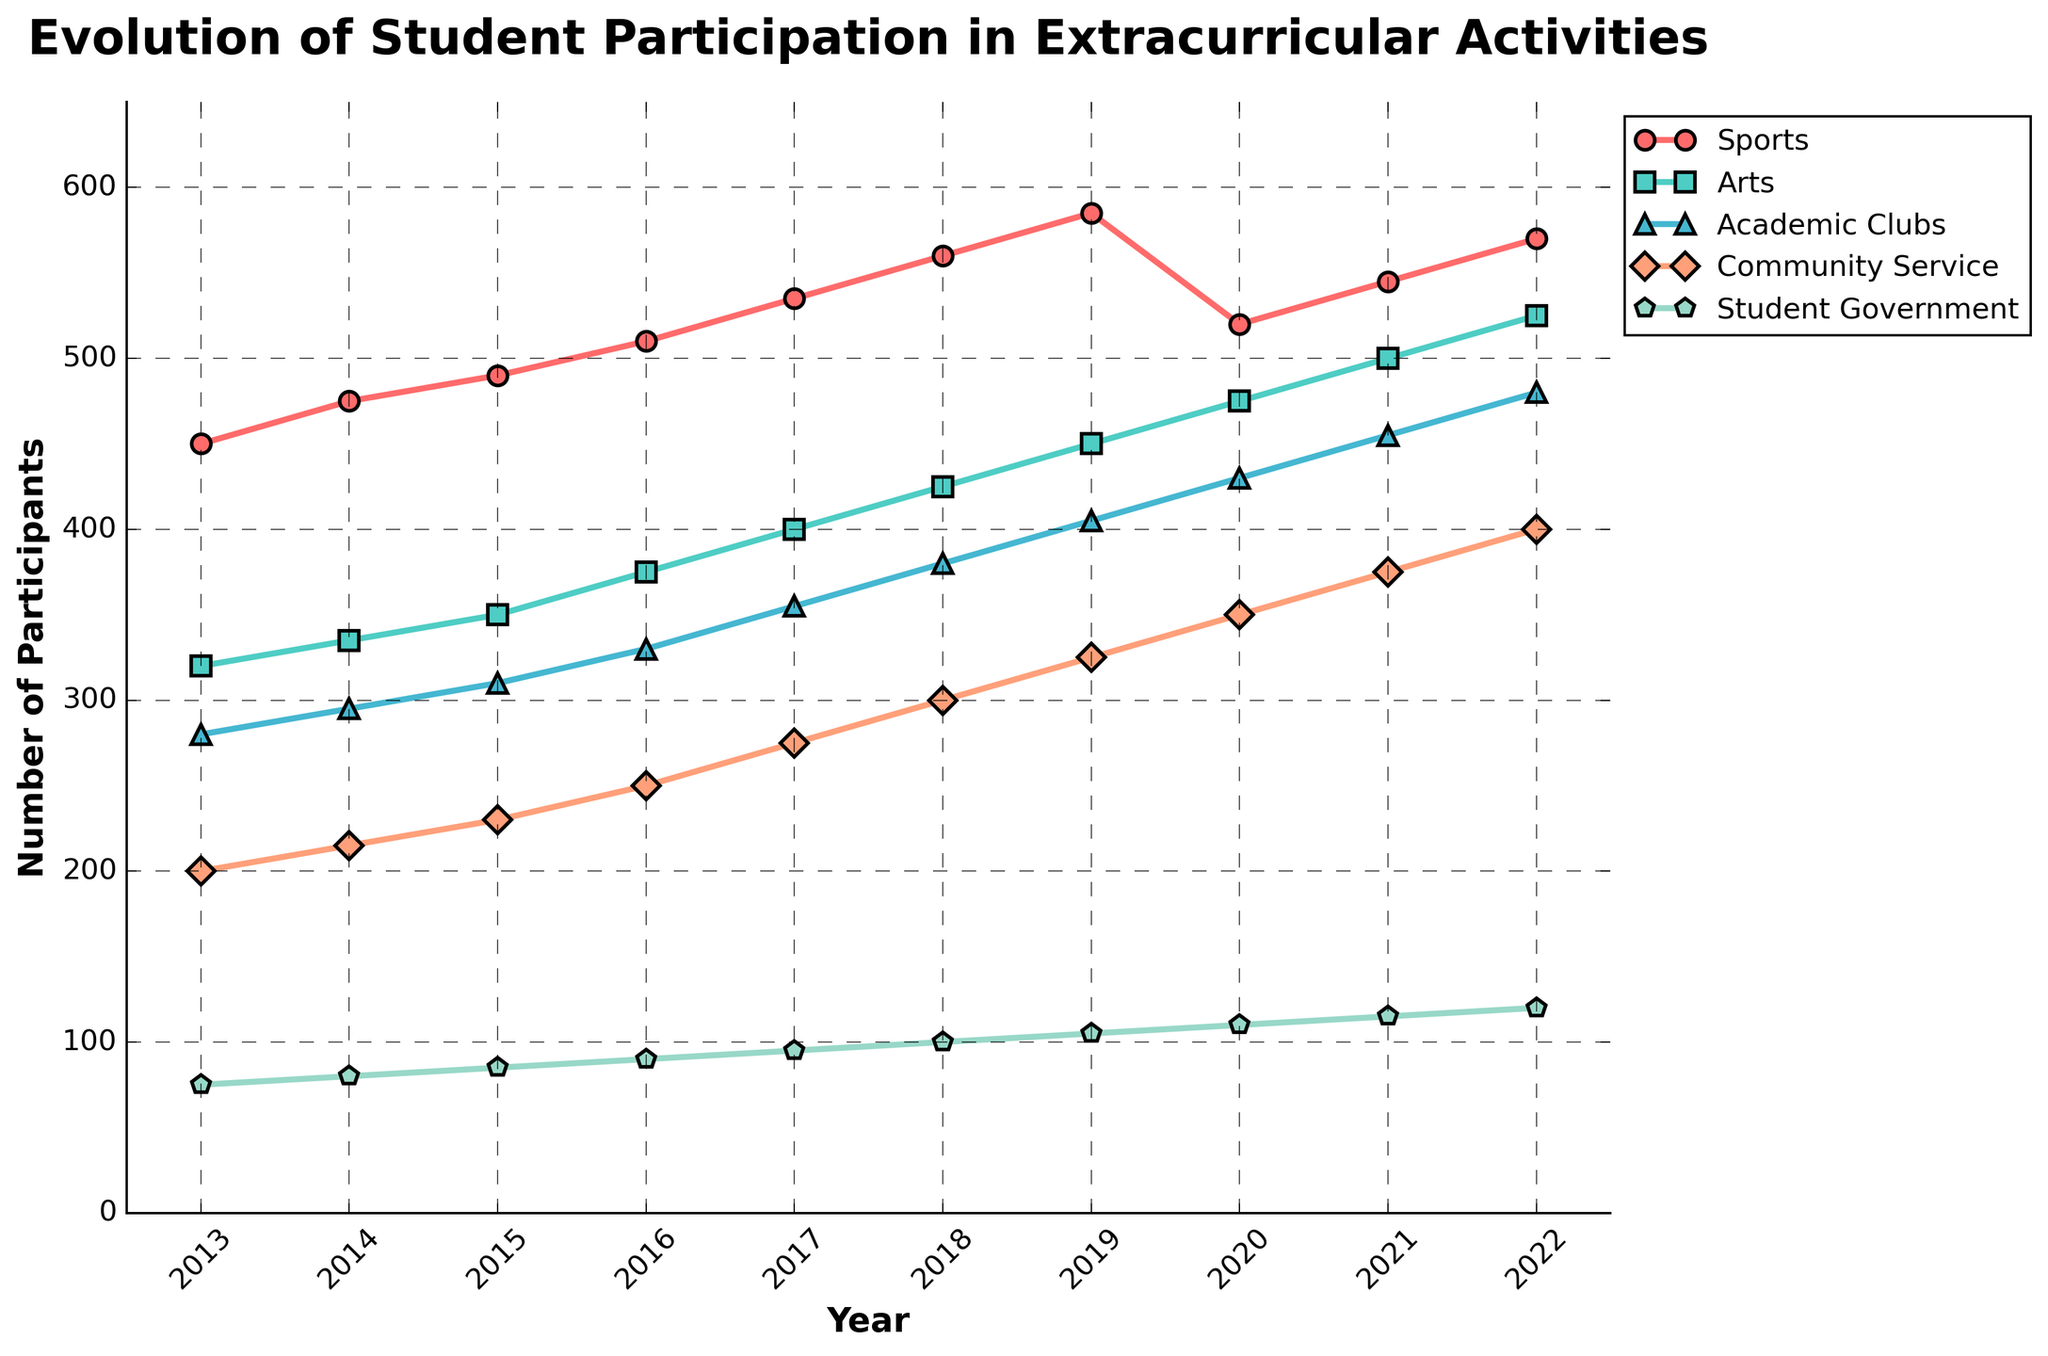What's the trend in student participation in Sports from 2013 to 2022? To find the trend in student participation in Sports from 2013 to 2022, look at the line corresponding to "Sports" in the chart. The line starts at 450 participants in 2013 and progressively increases year by year, reaching 570 participants in 2022. This indicates a general upward trend.
Answer: Upward trend In which year did Academic Clubs see the highest participation? To determine the year with the highest participation in Academic Clubs, look at the peak point of the line representing "Academic Clubs". The highest point occurs in 2022, with 480 participants.
Answer: 2022 By how much did participation in Community Service increase from 2013 to 2022? To find the increase in participation, subtract the number of participants in 2013 from the number of participants in 2022 for Community Service. It was 200 in 2013 and 400 in 2022. The difference is 400 - 200.
Answer: 200 Which activity had the least participants in 2013, and how many participants were there? To find the activity with the least participants in 2013, compare the starting points of all lines in that year. "Student Government" had the fewest participants with 75 participants.
Answer: Student Government, 75 participants Which two activities had exactly the same number of participants in any of the given years? Examine the points for each activity line for a year where two lines intersect. In 2019, "Academic Clubs" and "Community Service" both had 325 participants, indicating the intersecting point.
Answer: Academic Clubs and Community Service in 2019 What's the average number of participants in Arts across the entire decade? Sum the number of participants in Arts over all the years (320 + 335 + 350 + 375 + 400 + 425 + 450 + 475 + 500 + 525) = 4155. There are 10 years, so the average is 4155 / 10.
Answer: 415.5 In which year did Sports see a dip in participation, and what was the number? Look for the year where the line representing "Sports" decreases. This occurs in 2020, with the number of participants being 520, down from 585 in 2019.
Answer: 2020, 520 participants What is the difference in participation between the most and least popular activities in 2022? Compare the participant numbers in 2022 for all activities. The most popular is Sports with 570 participants, and the least popular is Student Government with 120 participants. The difference is 570 - 120.
Answer: 450 How many activities saw a continuous increase in participation every year from 2013 to 2022? To determine this, look at each activity's line and check if it continually increases without any dips from 2013 to 2022. "Student Government" and "Arts" follow this pattern.
Answer: 2 activities By what percentage did participation in Student Government increase from 2013 to 2022? Calculate the percentage increase using the formula [(final value - initial value) / initial value] * 100. For Student Government: [(120 - 75)/75] * 100.
Answer: 60% 